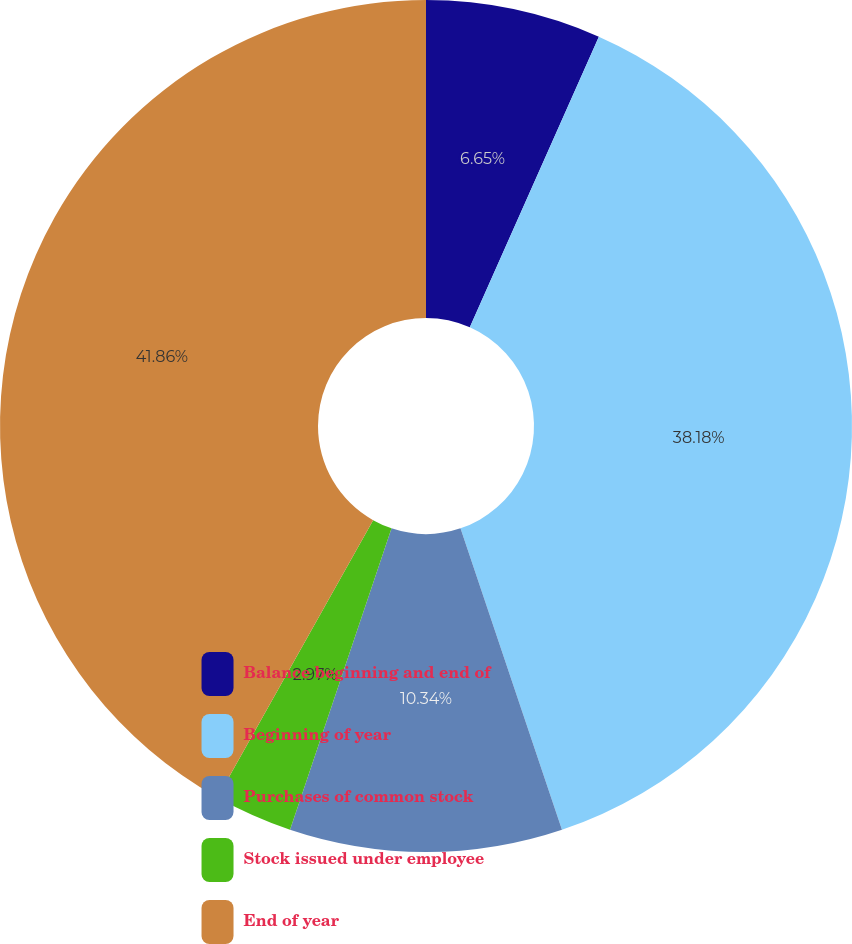Convert chart to OTSL. <chart><loc_0><loc_0><loc_500><loc_500><pie_chart><fcel>Balance beginning and end of<fcel>Beginning of year<fcel>Purchases of common stock<fcel>Stock issued under employee<fcel>End of year<nl><fcel>6.65%<fcel>38.18%<fcel>10.34%<fcel>2.97%<fcel>41.86%<nl></chart> 